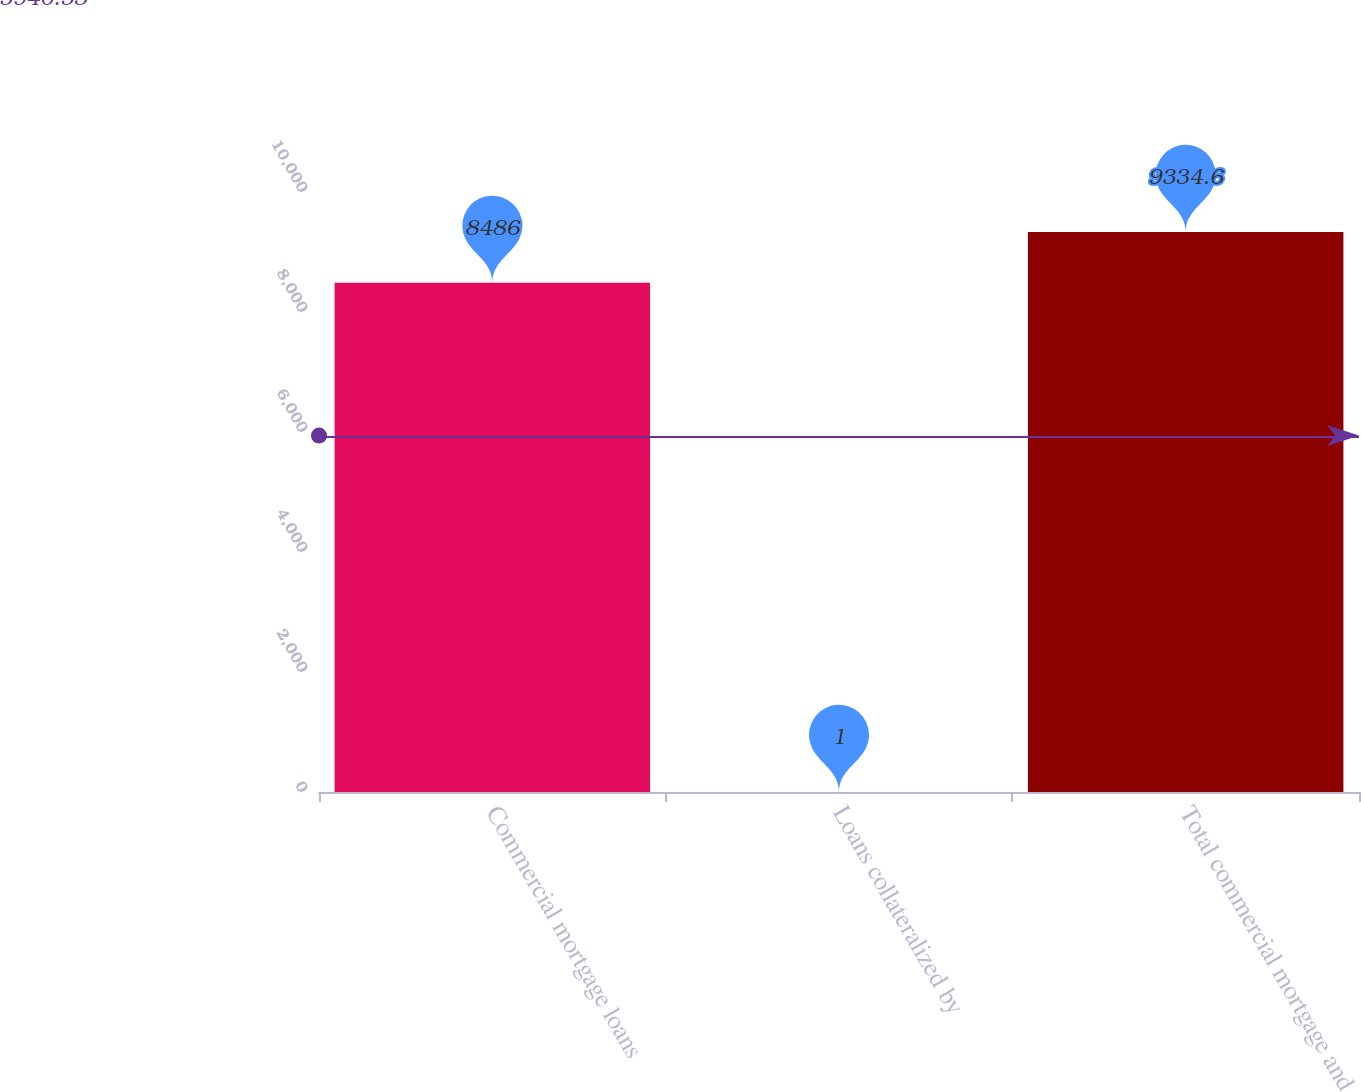Convert chart. <chart><loc_0><loc_0><loc_500><loc_500><bar_chart><fcel>Commercial mortgage loans<fcel>Loans collateralized by<fcel>Total commercial mortgage and<nl><fcel>8486<fcel>1<fcel>9334.6<nl></chart> 